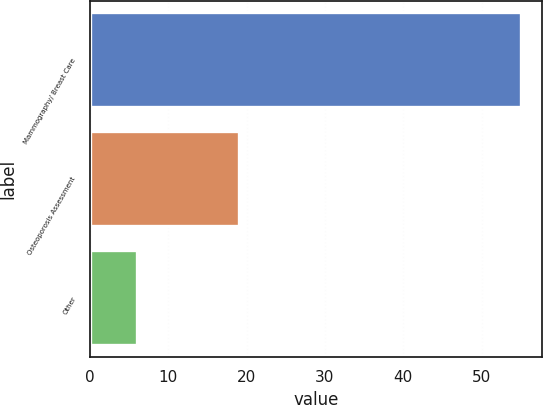<chart> <loc_0><loc_0><loc_500><loc_500><bar_chart><fcel>Mammography/ Breast Care<fcel>Osteoporosis Assessment<fcel>Other<nl><fcel>55<fcel>19<fcel>6<nl></chart> 